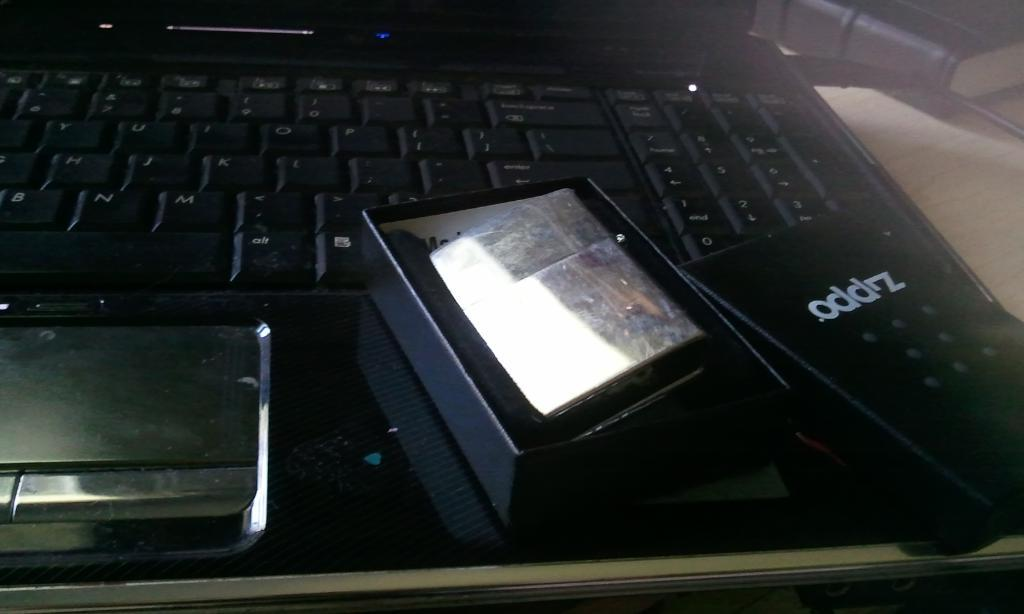<image>
Render a clear and concise summary of the photo. A Zippo brand lighter sits in a black box on top of a laptop keyboard. 